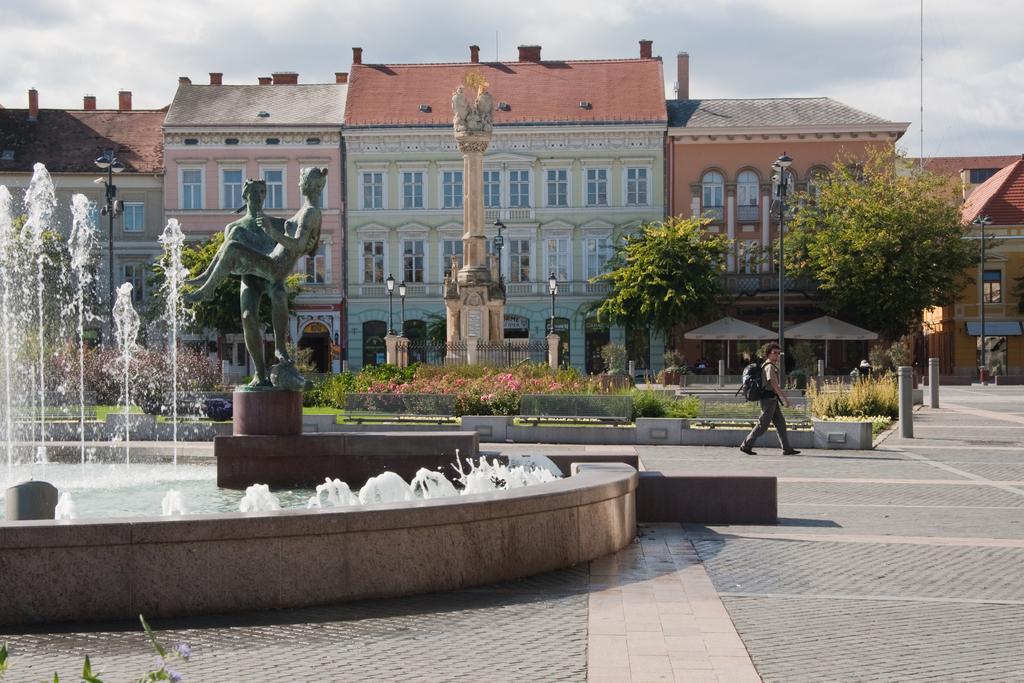Please provide a concise description of this image. In this image we can see fountain. In the middle of the fountain one statue is present. Background of the image buildings, plants, trees, moles are present. In front of the building one pillar is there. The sky is covered with clouds. 